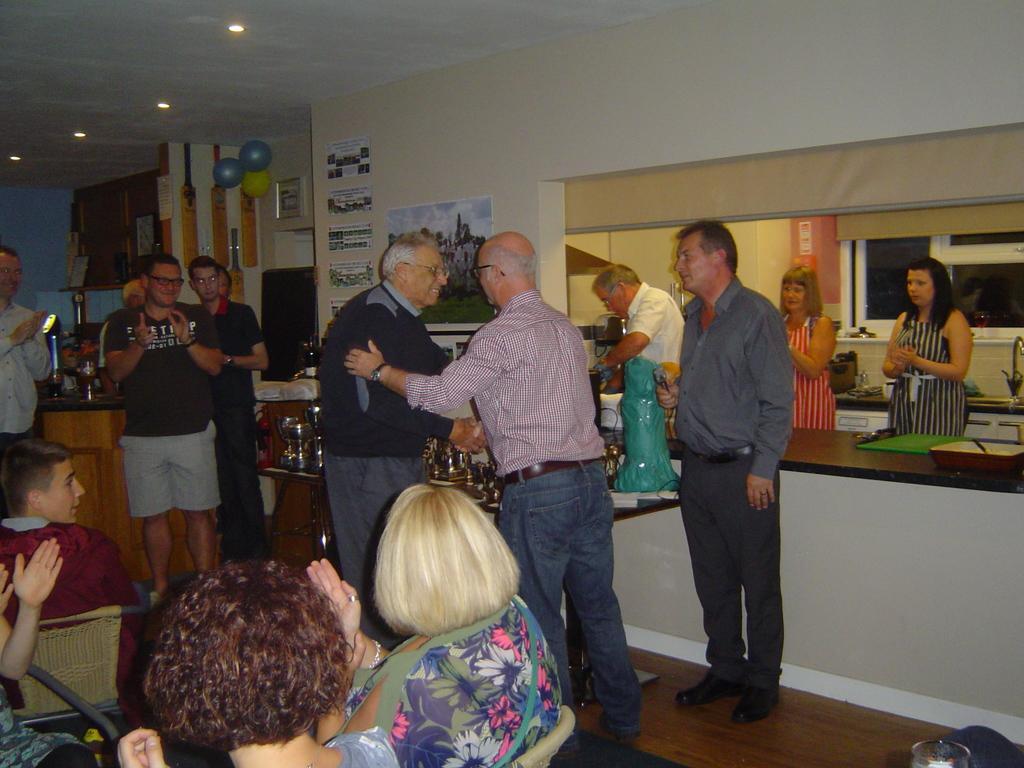In one or two sentences, can you explain what this image depicts? In the middle two old men are shaking their hands, in the right side two women are standing. In the left side few people are sitting on the chairs. 